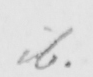Please transcribe the handwritten text in this image. ib . 